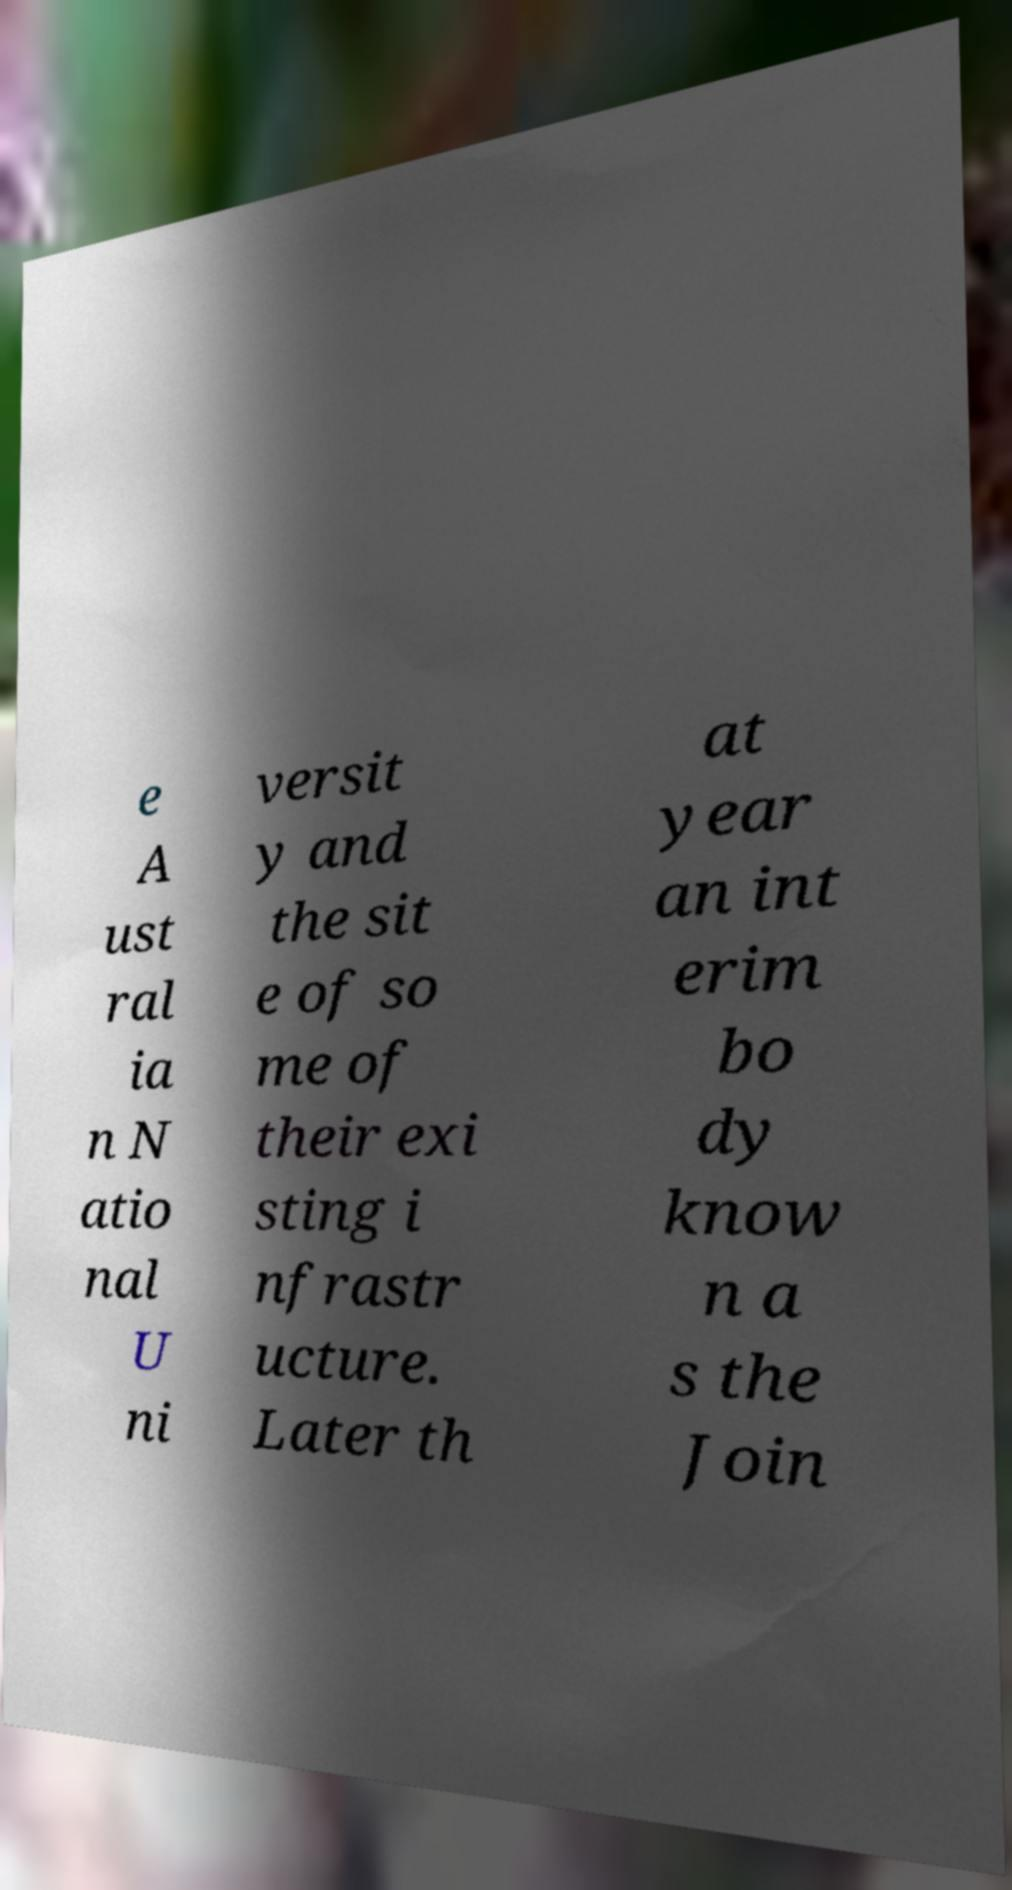Please read and relay the text visible in this image. What does it say? e A ust ral ia n N atio nal U ni versit y and the sit e of so me of their exi sting i nfrastr ucture. Later th at year an int erim bo dy know n a s the Join 